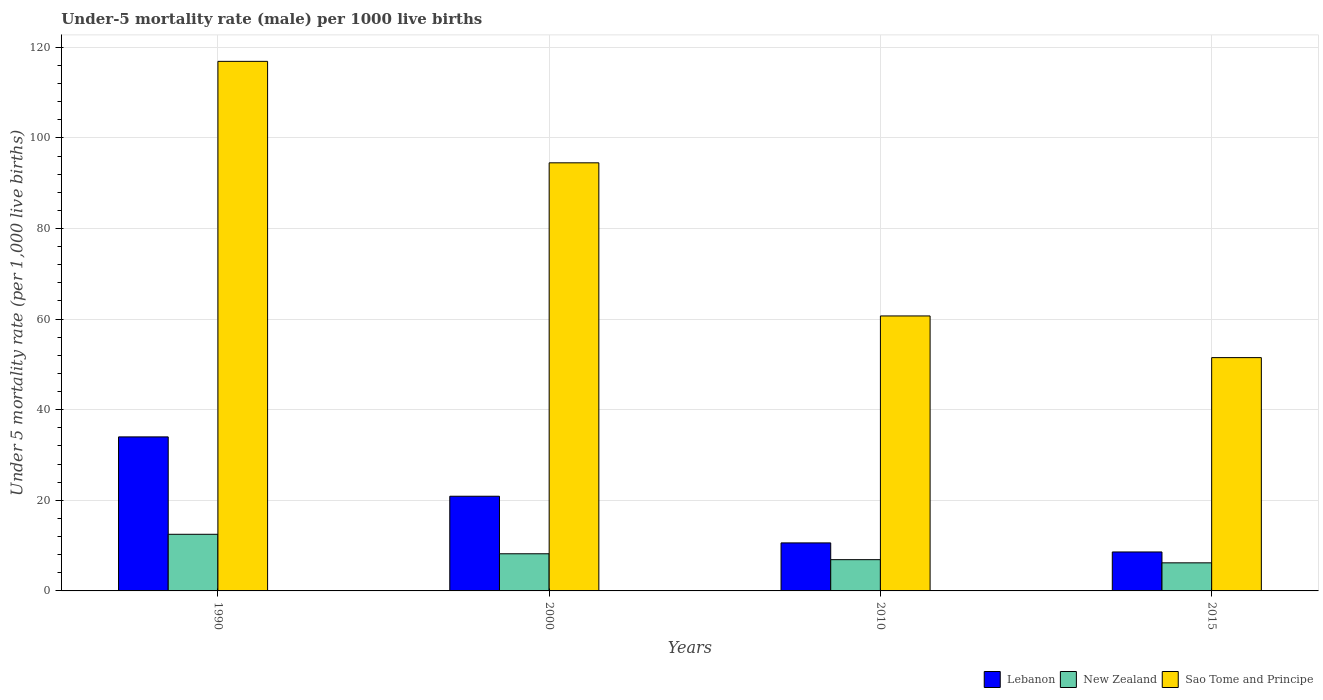Are the number of bars on each tick of the X-axis equal?
Keep it short and to the point. Yes. How many bars are there on the 2nd tick from the left?
Your response must be concise. 3. How many bars are there on the 3rd tick from the right?
Your answer should be compact. 3. In which year was the under-five mortality rate in Lebanon maximum?
Provide a succinct answer. 1990. In which year was the under-five mortality rate in Sao Tome and Principe minimum?
Make the answer very short. 2015. What is the total under-five mortality rate in Sao Tome and Principe in the graph?
Provide a succinct answer. 323.6. What is the difference between the under-five mortality rate in Sao Tome and Principe in 1990 and that in 2010?
Provide a short and direct response. 56.2. What is the difference between the under-five mortality rate in New Zealand in 2010 and the under-five mortality rate in Sao Tome and Principe in 1990?
Your response must be concise. -110. What is the average under-five mortality rate in New Zealand per year?
Your answer should be compact. 8.45. In the year 2015, what is the difference between the under-five mortality rate in Lebanon and under-five mortality rate in Sao Tome and Principe?
Keep it short and to the point. -42.9. What is the ratio of the under-five mortality rate in Lebanon in 2000 to that in 2010?
Give a very brief answer. 1.97. What is the difference between the highest and the second highest under-five mortality rate in Lebanon?
Your answer should be very brief. 13.1. What is the difference between the highest and the lowest under-five mortality rate in Lebanon?
Make the answer very short. 25.4. In how many years, is the under-five mortality rate in New Zealand greater than the average under-five mortality rate in New Zealand taken over all years?
Offer a terse response. 1. What does the 3rd bar from the left in 2015 represents?
Provide a short and direct response. Sao Tome and Principe. What does the 1st bar from the right in 2015 represents?
Provide a short and direct response. Sao Tome and Principe. Is it the case that in every year, the sum of the under-five mortality rate in Sao Tome and Principe and under-five mortality rate in New Zealand is greater than the under-five mortality rate in Lebanon?
Your answer should be very brief. Yes. How many bars are there?
Provide a succinct answer. 12. Are all the bars in the graph horizontal?
Ensure brevity in your answer.  No. How many years are there in the graph?
Give a very brief answer. 4. Are the values on the major ticks of Y-axis written in scientific E-notation?
Provide a short and direct response. No. What is the title of the graph?
Offer a terse response. Under-5 mortality rate (male) per 1000 live births. Does "New Zealand" appear as one of the legend labels in the graph?
Provide a succinct answer. Yes. What is the label or title of the X-axis?
Keep it short and to the point. Years. What is the label or title of the Y-axis?
Your answer should be very brief. Under 5 mortality rate (per 1,0 live births). What is the Under 5 mortality rate (per 1,000 live births) in Lebanon in 1990?
Provide a succinct answer. 34. What is the Under 5 mortality rate (per 1,000 live births) in Sao Tome and Principe in 1990?
Offer a terse response. 116.9. What is the Under 5 mortality rate (per 1,000 live births) in Lebanon in 2000?
Your response must be concise. 20.9. What is the Under 5 mortality rate (per 1,000 live births) of New Zealand in 2000?
Keep it short and to the point. 8.2. What is the Under 5 mortality rate (per 1,000 live births) in Sao Tome and Principe in 2000?
Keep it short and to the point. 94.5. What is the Under 5 mortality rate (per 1,000 live births) in Lebanon in 2010?
Offer a very short reply. 10.6. What is the Under 5 mortality rate (per 1,000 live births) of Sao Tome and Principe in 2010?
Your answer should be compact. 60.7. What is the Under 5 mortality rate (per 1,000 live births) in Lebanon in 2015?
Provide a short and direct response. 8.6. What is the Under 5 mortality rate (per 1,000 live births) of Sao Tome and Principe in 2015?
Offer a terse response. 51.5. Across all years, what is the maximum Under 5 mortality rate (per 1,000 live births) in Lebanon?
Keep it short and to the point. 34. Across all years, what is the maximum Under 5 mortality rate (per 1,000 live births) of New Zealand?
Your answer should be very brief. 12.5. Across all years, what is the maximum Under 5 mortality rate (per 1,000 live births) in Sao Tome and Principe?
Give a very brief answer. 116.9. Across all years, what is the minimum Under 5 mortality rate (per 1,000 live births) in Lebanon?
Your answer should be compact. 8.6. Across all years, what is the minimum Under 5 mortality rate (per 1,000 live births) in Sao Tome and Principe?
Offer a terse response. 51.5. What is the total Under 5 mortality rate (per 1,000 live births) of Lebanon in the graph?
Your response must be concise. 74.1. What is the total Under 5 mortality rate (per 1,000 live births) in New Zealand in the graph?
Provide a succinct answer. 33.8. What is the total Under 5 mortality rate (per 1,000 live births) in Sao Tome and Principe in the graph?
Make the answer very short. 323.6. What is the difference between the Under 5 mortality rate (per 1,000 live births) in Lebanon in 1990 and that in 2000?
Your answer should be very brief. 13.1. What is the difference between the Under 5 mortality rate (per 1,000 live births) in New Zealand in 1990 and that in 2000?
Provide a succinct answer. 4.3. What is the difference between the Under 5 mortality rate (per 1,000 live births) of Sao Tome and Principe in 1990 and that in 2000?
Offer a terse response. 22.4. What is the difference between the Under 5 mortality rate (per 1,000 live births) in Lebanon in 1990 and that in 2010?
Ensure brevity in your answer.  23.4. What is the difference between the Under 5 mortality rate (per 1,000 live births) in Sao Tome and Principe in 1990 and that in 2010?
Give a very brief answer. 56.2. What is the difference between the Under 5 mortality rate (per 1,000 live births) of Lebanon in 1990 and that in 2015?
Provide a succinct answer. 25.4. What is the difference between the Under 5 mortality rate (per 1,000 live births) in Sao Tome and Principe in 1990 and that in 2015?
Your answer should be compact. 65.4. What is the difference between the Under 5 mortality rate (per 1,000 live births) of Lebanon in 2000 and that in 2010?
Give a very brief answer. 10.3. What is the difference between the Under 5 mortality rate (per 1,000 live births) of Sao Tome and Principe in 2000 and that in 2010?
Keep it short and to the point. 33.8. What is the difference between the Under 5 mortality rate (per 1,000 live births) of Lebanon in 1990 and the Under 5 mortality rate (per 1,000 live births) of New Zealand in 2000?
Make the answer very short. 25.8. What is the difference between the Under 5 mortality rate (per 1,000 live births) in Lebanon in 1990 and the Under 5 mortality rate (per 1,000 live births) in Sao Tome and Principe in 2000?
Provide a short and direct response. -60.5. What is the difference between the Under 5 mortality rate (per 1,000 live births) of New Zealand in 1990 and the Under 5 mortality rate (per 1,000 live births) of Sao Tome and Principe in 2000?
Your answer should be compact. -82. What is the difference between the Under 5 mortality rate (per 1,000 live births) of Lebanon in 1990 and the Under 5 mortality rate (per 1,000 live births) of New Zealand in 2010?
Provide a succinct answer. 27.1. What is the difference between the Under 5 mortality rate (per 1,000 live births) in Lebanon in 1990 and the Under 5 mortality rate (per 1,000 live births) in Sao Tome and Principe in 2010?
Give a very brief answer. -26.7. What is the difference between the Under 5 mortality rate (per 1,000 live births) of New Zealand in 1990 and the Under 5 mortality rate (per 1,000 live births) of Sao Tome and Principe in 2010?
Your response must be concise. -48.2. What is the difference between the Under 5 mortality rate (per 1,000 live births) in Lebanon in 1990 and the Under 5 mortality rate (per 1,000 live births) in New Zealand in 2015?
Make the answer very short. 27.8. What is the difference between the Under 5 mortality rate (per 1,000 live births) in Lebanon in 1990 and the Under 5 mortality rate (per 1,000 live births) in Sao Tome and Principe in 2015?
Provide a short and direct response. -17.5. What is the difference between the Under 5 mortality rate (per 1,000 live births) of New Zealand in 1990 and the Under 5 mortality rate (per 1,000 live births) of Sao Tome and Principe in 2015?
Offer a terse response. -39. What is the difference between the Under 5 mortality rate (per 1,000 live births) in Lebanon in 2000 and the Under 5 mortality rate (per 1,000 live births) in Sao Tome and Principe in 2010?
Ensure brevity in your answer.  -39.8. What is the difference between the Under 5 mortality rate (per 1,000 live births) of New Zealand in 2000 and the Under 5 mortality rate (per 1,000 live births) of Sao Tome and Principe in 2010?
Your answer should be compact. -52.5. What is the difference between the Under 5 mortality rate (per 1,000 live births) in Lebanon in 2000 and the Under 5 mortality rate (per 1,000 live births) in New Zealand in 2015?
Make the answer very short. 14.7. What is the difference between the Under 5 mortality rate (per 1,000 live births) in Lebanon in 2000 and the Under 5 mortality rate (per 1,000 live births) in Sao Tome and Principe in 2015?
Provide a short and direct response. -30.6. What is the difference between the Under 5 mortality rate (per 1,000 live births) of New Zealand in 2000 and the Under 5 mortality rate (per 1,000 live births) of Sao Tome and Principe in 2015?
Offer a very short reply. -43.3. What is the difference between the Under 5 mortality rate (per 1,000 live births) in Lebanon in 2010 and the Under 5 mortality rate (per 1,000 live births) in Sao Tome and Principe in 2015?
Make the answer very short. -40.9. What is the difference between the Under 5 mortality rate (per 1,000 live births) in New Zealand in 2010 and the Under 5 mortality rate (per 1,000 live births) in Sao Tome and Principe in 2015?
Keep it short and to the point. -44.6. What is the average Under 5 mortality rate (per 1,000 live births) in Lebanon per year?
Give a very brief answer. 18.52. What is the average Under 5 mortality rate (per 1,000 live births) in New Zealand per year?
Make the answer very short. 8.45. What is the average Under 5 mortality rate (per 1,000 live births) in Sao Tome and Principe per year?
Your response must be concise. 80.9. In the year 1990, what is the difference between the Under 5 mortality rate (per 1,000 live births) in Lebanon and Under 5 mortality rate (per 1,000 live births) in Sao Tome and Principe?
Give a very brief answer. -82.9. In the year 1990, what is the difference between the Under 5 mortality rate (per 1,000 live births) in New Zealand and Under 5 mortality rate (per 1,000 live births) in Sao Tome and Principe?
Make the answer very short. -104.4. In the year 2000, what is the difference between the Under 5 mortality rate (per 1,000 live births) in Lebanon and Under 5 mortality rate (per 1,000 live births) in Sao Tome and Principe?
Offer a very short reply. -73.6. In the year 2000, what is the difference between the Under 5 mortality rate (per 1,000 live births) in New Zealand and Under 5 mortality rate (per 1,000 live births) in Sao Tome and Principe?
Offer a terse response. -86.3. In the year 2010, what is the difference between the Under 5 mortality rate (per 1,000 live births) of Lebanon and Under 5 mortality rate (per 1,000 live births) of New Zealand?
Your answer should be very brief. 3.7. In the year 2010, what is the difference between the Under 5 mortality rate (per 1,000 live births) in Lebanon and Under 5 mortality rate (per 1,000 live births) in Sao Tome and Principe?
Offer a very short reply. -50.1. In the year 2010, what is the difference between the Under 5 mortality rate (per 1,000 live births) in New Zealand and Under 5 mortality rate (per 1,000 live births) in Sao Tome and Principe?
Offer a very short reply. -53.8. In the year 2015, what is the difference between the Under 5 mortality rate (per 1,000 live births) of Lebanon and Under 5 mortality rate (per 1,000 live births) of Sao Tome and Principe?
Provide a succinct answer. -42.9. In the year 2015, what is the difference between the Under 5 mortality rate (per 1,000 live births) of New Zealand and Under 5 mortality rate (per 1,000 live births) of Sao Tome and Principe?
Offer a very short reply. -45.3. What is the ratio of the Under 5 mortality rate (per 1,000 live births) of Lebanon in 1990 to that in 2000?
Your response must be concise. 1.63. What is the ratio of the Under 5 mortality rate (per 1,000 live births) of New Zealand in 1990 to that in 2000?
Offer a very short reply. 1.52. What is the ratio of the Under 5 mortality rate (per 1,000 live births) of Sao Tome and Principe in 1990 to that in 2000?
Your response must be concise. 1.24. What is the ratio of the Under 5 mortality rate (per 1,000 live births) in Lebanon in 1990 to that in 2010?
Your answer should be very brief. 3.21. What is the ratio of the Under 5 mortality rate (per 1,000 live births) of New Zealand in 1990 to that in 2010?
Offer a terse response. 1.81. What is the ratio of the Under 5 mortality rate (per 1,000 live births) in Sao Tome and Principe in 1990 to that in 2010?
Your answer should be compact. 1.93. What is the ratio of the Under 5 mortality rate (per 1,000 live births) of Lebanon in 1990 to that in 2015?
Your answer should be very brief. 3.95. What is the ratio of the Under 5 mortality rate (per 1,000 live births) in New Zealand in 1990 to that in 2015?
Keep it short and to the point. 2.02. What is the ratio of the Under 5 mortality rate (per 1,000 live births) in Sao Tome and Principe in 1990 to that in 2015?
Keep it short and to the point. 2.27. What is the ratio of the Under 5 mortality rate (per 1,000 live births) of Lebanon in 2000 to that in 2010?
Keep it short and to the point. 1.97. What is the ratio of the Under 5 mortality rate (per 1,000 live births) in New Zealand in 2000 to that in 2010?
Offer a terse response. 1.19. What is the ratio of the Under 5 mortality rate (per 1,000 live births) of Sao Tome and Principe in 2000 to that in 2010?
Provide a short and direct response. 1.56. What is the ratio of the Under 5 mortality rate (per 1,000 live births) of Lebanon in 2000 to that in 2015?
Provide a succinct answer. 2.43. What is the ratio of the Under 5 mortality rate (per 1,000 live births) in New Zealand in 2000 to that in 2015?
Your answer should be compact. 1.32. What is the ratio of the Under 5 mortality rate (per 1,000 live births) in Sao Tome and Principe in 2000 to that in 2015?
Give a very brief answer. 1.83. What is the ratio of the Under 5 mortality rate (per 1,000 live births) in Lebanon in 2010 to that in 2015?
Give a very brief answer. 1.23. What is the ratio of the Under 5 mortality rate (per 1,000 live births) of New Zealand in 2010 to that in 2015?
Make the answer very short. 1.11. What is the ratio of the Under 5 mortality rate (per 1,000 live births) of Sao Tome and Principe in 2010 to that in 2015?
Make the answer very short. 1.18. What is the difference between the highest and the second highest Under 5 mortality rate (per 1,000 live births) of Lebanon?
Ensure brevity in your answer.  13.1. What is the difference between the highest and the second highest Under 5 mortality rate (per 1,000 live births) of New Zealand?
Offer a very short reply. 4.3. What is the difference between the highest and the second highest Under 5 mortality rate (per 1,000 live births) in Sao Tome and Principe?
Offer a terse response. 22.4. What is the difference between the highest and the lowest Under 5 mortality rate (per 1,000 live births) in Lebanon?
Provide a succinct answer. 25.4. What is the difference between the highest and the lowest Under 5 mortality rate (per 1,000 live births) in New Zealand?
Provide a short and direct response. 6.3. What is the difference between the highest and the lowest Under 5 mortality rate (per 1,000 live births) in Sao Tome and Principe?
Offer a terse response. 65.4. 